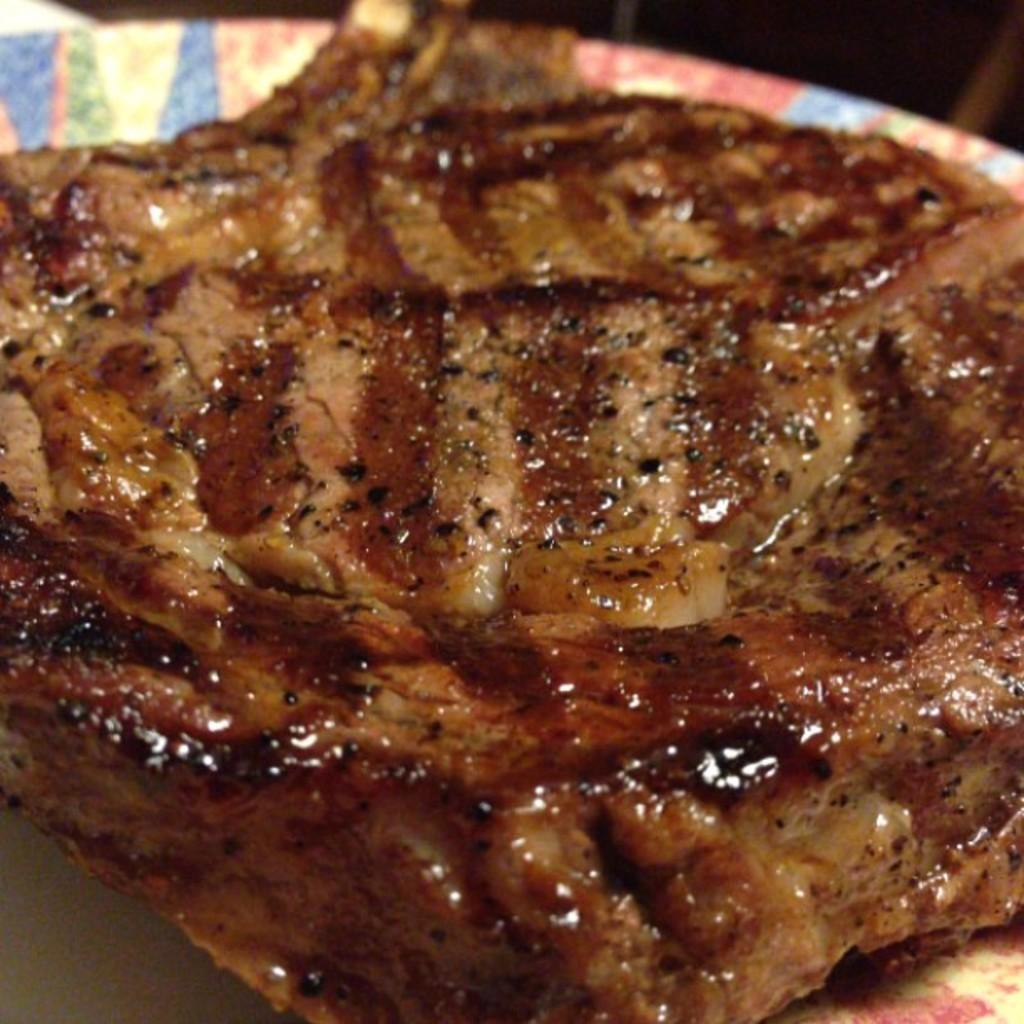What is placed on the table in the image? There is meat placed on a table in the image. What type of twig can be seen growing from the meat in the image? There is no twig growing from the meat in the image; it is simply meat placed on a table. What trick is being performed with the meat in the image? There is no trick being performed with the meat in the image; it is just meat placed on a table. 